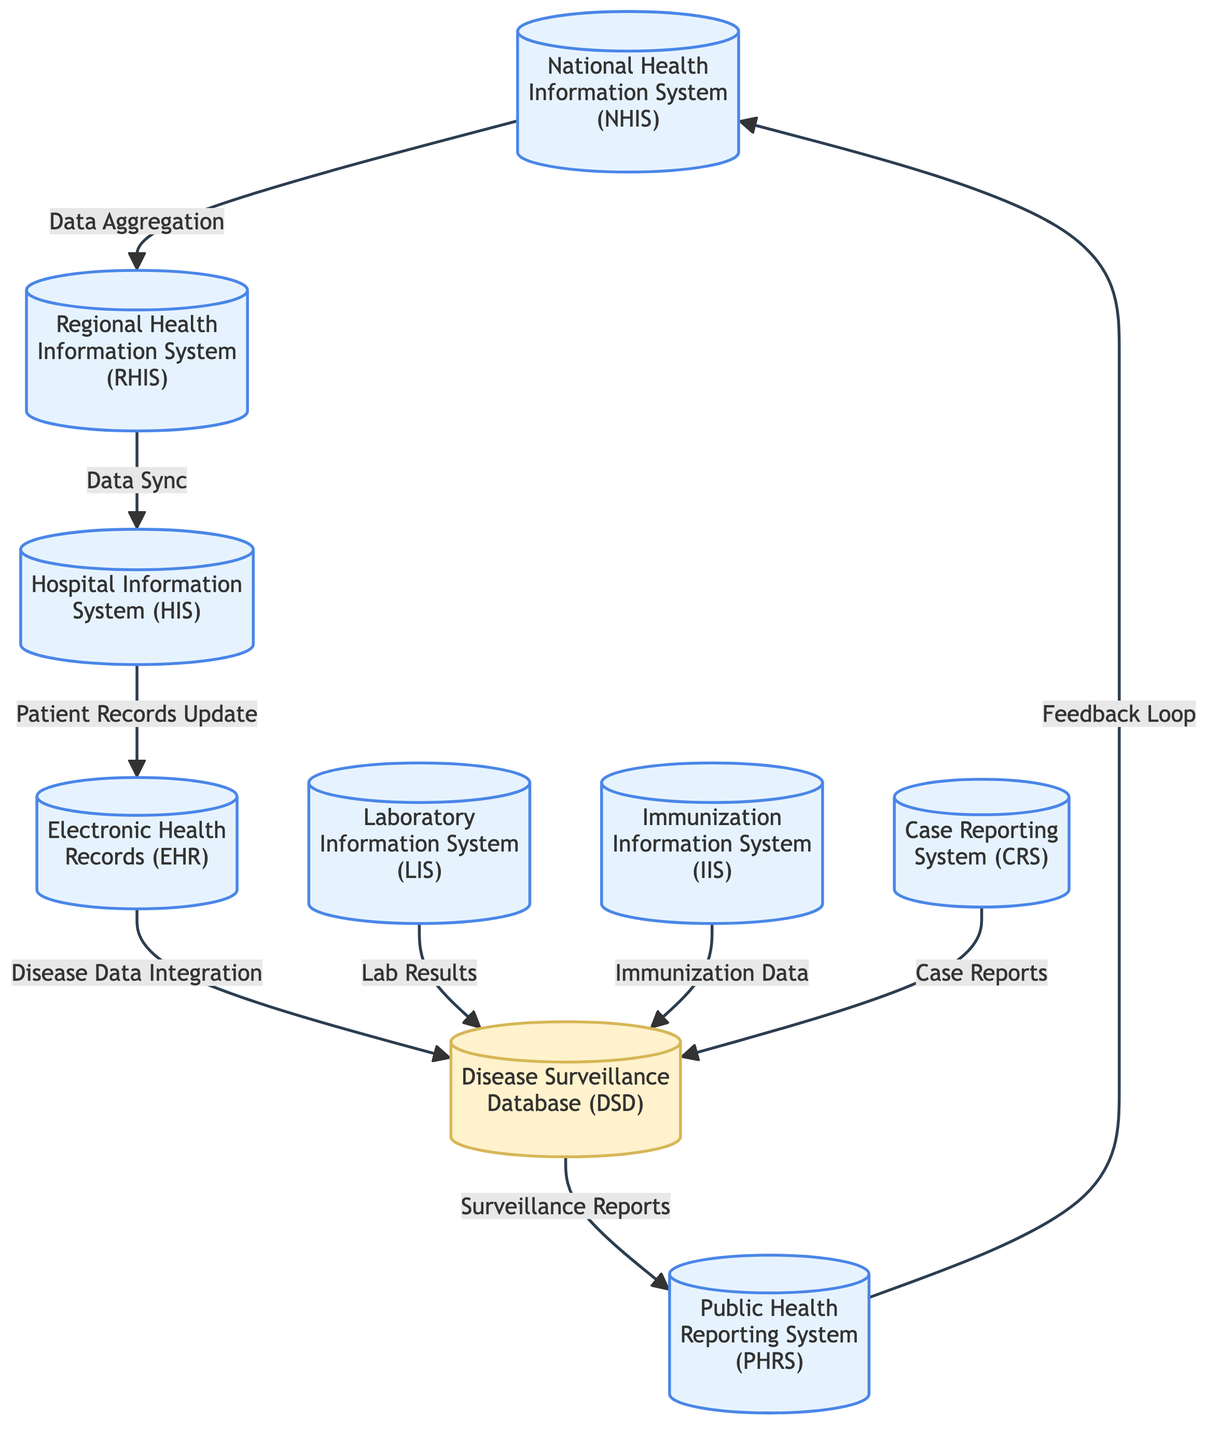What is the total number of systems and databases represented in the diagram? The diagram includes 9 systems and 1 database. Counting them gives a total of 10 nodes.
Answer: 10 Which system is responsible for receiving disease data integration? The Electronic Health Records (EHR) system is responsible for integrating disease data before sending it to the Disease Surveillance Database (DSD).
Answer: Electronic Health Records What type of information does the Laboratory Information System (LIS) send to the Disease Surveillance Database? The LIS sends laboratory results to the DSD as part of the data flow.
Answer: Lab Results How does the National Health Information System relate to the Regional Health Information System? The NHIS provides data aggregation to the RHIS, indicating a one-way relationship where data is transferred from NHIS to RHIS.
Answer: Data Aggregation What is the direction of the feedback loop in the diagram? The feedback loop goes from the Public Health Reporting System (PHRS) back to the National Health Information System (NHIS).
Answer: PHRS to National Health Information System Which system is directly linked to sending case reports to the Disease Surveillance Database? The Case Reporting System (CRS) is directly responsible for sending case reports to the DSD.
Answer: Case Reporting System What is the primary function of the Disease Surveillance Database? The primary function of the DSD is to compile and analyze surveillance data from various sources before reporting to the PHRS.
Answer: Compile and analyze surveillance data What kind of data does the Immunization Information System (IIS) provide to the Disease Surveillance Database? The IIS supplies immunization data to the DSD, contributing to the overall disease surveillance efforts.
Answer: Immunization Data 